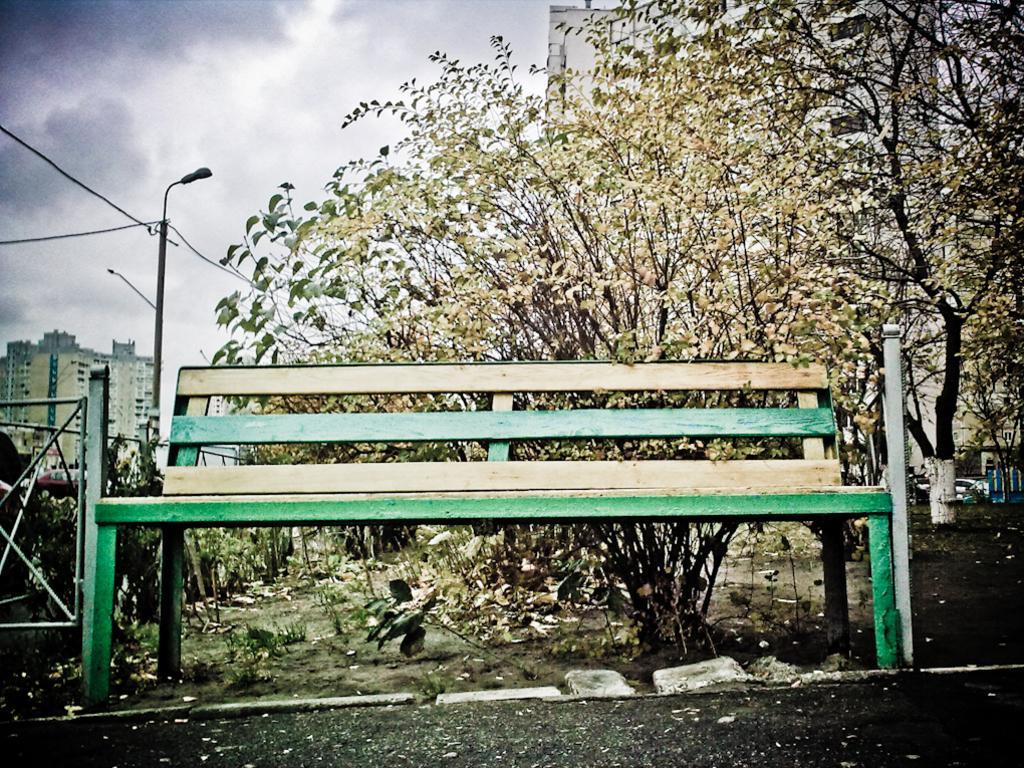Could you give a brief overview of what you see in this image? In the image we can see there is a bench which is kept on the ground. Behind there are trees and there are buildings, on the other side there is a street light pole. 